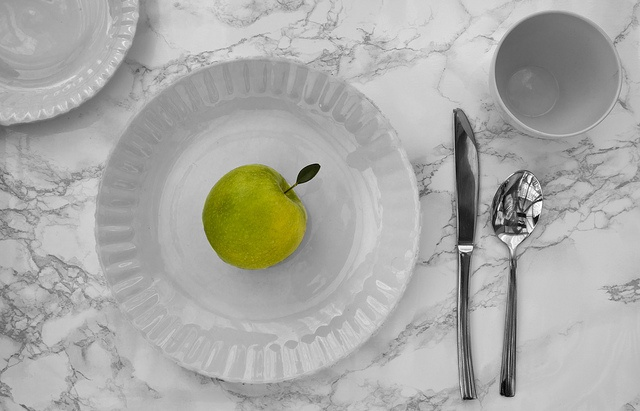Describe the objects in this image and their specific colors. I can see dining table in darkgray, lightgray, gray, and olive tones, bowl in darkgray, gray, and lightgray tones, cup in darkgray, gray, and lightgray tones, bowl in darkgray, lightgray, and gray tones, and apple in darkgray and olive tones in this image. 